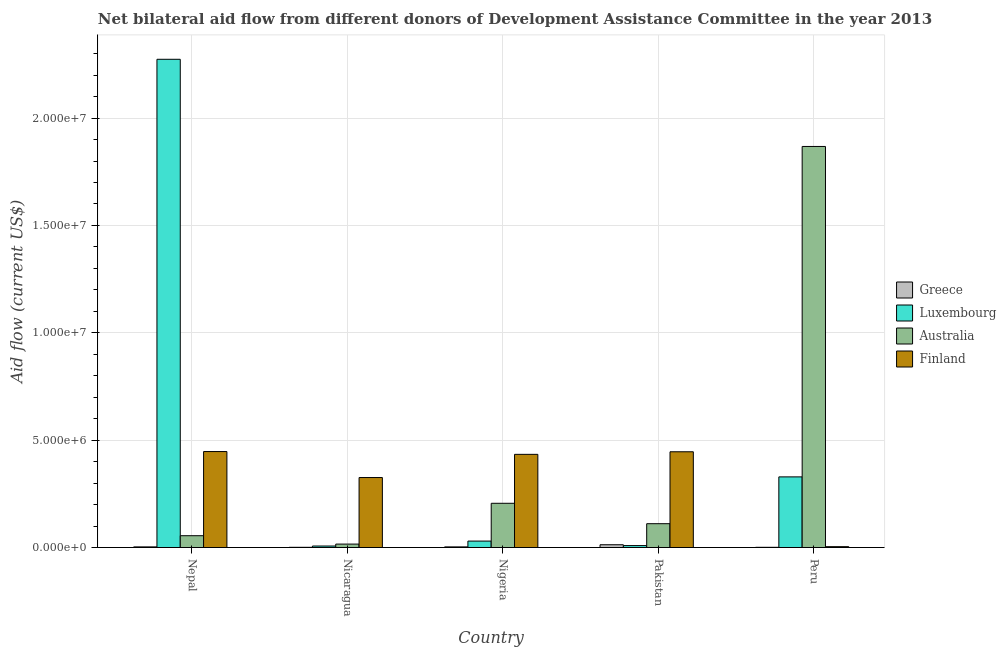How many groups of bars are there?
Offer a very short reply. 5. Are the number of bars per tick equal to the number of legend labels?
Provide a short and direct response. Yes. Are the number of bars on each tick of the X-axis equal?
Your answer should be compact. Yes. How many bars are there on the 5th tick from the right?
Keep it short and to the point. 4. What is the label of the 3rd group of bars from the left?
Your response must be concise. Nigeria. In how many cases, is the number of bars for a given country not equal to the number of legend labels?
Keep it short and to the point. 0. What is the amount of aid given by greece in Nepal?
Keep it short and to the point. 3.00e+04. Across all countries, what is the maximum amount of aid given by greece?
Your response must be concise. 1.30e+05. Across all countries, what is the minimum amount of aid given by greece?
Provide a short and direct response. 10000. In which country was the amount of aid given by greece maximum?
Give a very brief answer. Pakistan. In which country was the amount of aid given by greece minimum?
Your response must be concise. Nicaragua. What is the total amount of aid given by luxembourg in the graph?
Your response must be concise. 2.65e+07. What is the difference between the amount of aid given by greece in Nigeria and that in Peru?
Make the answer very short. 2.00e+04. What is the difference between the amount of aid given by luxembourg in Nepal and the amount of aid given by greece in Nicaragua?
Provide a short and direct response. 2.27e+07. What is the average amount of aid given by luxembourg per country?
Offer a terse response. 5.30e+06. What is the difference between the amount of aid given by luxembourg and amount of aid given by finland in Nigeria?
Give a very brief answer. -4.04e+06. In how many countries, is the amount of aid given by luxembourg greater than 22000000 US$?
Your response must be concise. 1. What is the ratio of the amount of aid given by luxembourg in Nepal to that in Nicaragua?
Your response must be concise. 324.86. Is the difference between the amount of aid given by australia in Nepal and Pakistan greater than the difference between the amount of aid given by greece in Nepal and Pakistan?
Provide a succinct answer. No. What is the difference between the highest and the second highest amount of aid given by finland?
Your answer should be compact. 10000. What is the difference between the highest and the lowest amount of aid given by greece?
Provide a short and direct response. 1.20e+05. What does the 2nd bar from the left in Pakistan represents?
Your response must be concise. Luxembourg. Is it the case that in every country, the sum of the amount of aid given by greece and amount of aid given by luxembourg is greater than the amount of aid given by australia?
Give a very brief answer. No. How many bars are there?
Keep it short and to the point. 20. What is the difference between two consecutive major ticks on the Y-axis?
Your answer should be compact. 5.00e+06. Are the values on the major ticks of Y-axis written in scientific E-notation?
Offer a very short reply. Yes. Does the graph contain grids?
Your response must be concise. Yes. How many legend labels are there?
Your response must be concise. 4. What is the title of the graph?
Your response must be concise. Net bilateral aid flow from different donors of Development Assistance Committee in the year 2013. Does "Taxes on income" appear as one of the legend labels in the graph?
Provide a succinct answer. No. What is the label or title of the X-axis?
Make the answer very short. Country. What is the label or title of the Y-axis?
Provide a succinct answer. Aid flow (current US$). What is the Aid flow (current US$) of Greece in Nepal?
Ensure brevity in your answer.  3.00e+04. What is the Aid flow (current US$) in Luxembourg in Nepal?
Make the answer very short. 2.27e+07. What is the Aid flow (current US$) of Australia in Nepal?
Your answer should be compact. 5.50e+05. What is the Aid flow (current US$) in Finland in Nepal?
Keep it short and to the point. 4.47e+06. What is the Aid flow (current US$) in Greece in Nicaragua?
Give a very brief answer. 10000. What is the Aid flow (current US$) in Luxembourg in Nicaragua?
Provide a short and direct response. 7.00e+04. What is the Aid flow (current US$) of Finland in Nicaragua?
Your answer should be compact. 3.26e+06. What is the Aid flow (current US$) in Greece in Nigeria?
Offer a terse response. 3.00e+04. What is the Aid flow (current US$) of Luxembourg in Nigeria?
Ensure brevity in your answer.  3.00e+05. What is the Aid flow (current US$) in Australia in Nigeria?
Ensure brevity in your answer.  2.06e+06. What is the Aid flow (current US$) of Finland in Nigeria?
Give a very brief answer. 4.34e+06. What is the Aid flow (current US$) of Greece in Pakistan?
Give a very brief answer. 1.30e+05. What is the Aid flow (current US$) in Luxembourg in Pakistan?
Your answer should be compact. 9.00e+04. What is the Aid flow (current US$) of Australia in Pakistan?
Give a very brief answer. 1.11e+06. What is the Aid flow (current US$) of Finland in Pakistan?
Your response must be concise. 4.46e+06. What is the Aid flow (current US$) in Greece in Peru?
Give a very brief answer. 10000. What is the Aid flow (current US$) in Luxembourg in Peru?
Ensure brevity in your answer.  3.29e+06. What is the Aid flow (current US$) of Australia in Peru?
Your answer should be very brief. 1.87e+07. Across all countries, what is the maximum Aid flow (current US$) in Greece?
Make the answer very short. 1.30e+05. Across all countries, what is the maximum Aid flow (current US$) of Luxembourg?
Provide a short and direct response. 2.27e+07. Across all countries, what is the maximum Aid flow (current US$) of Australia?
Keep it short and to the point. 1.87e+07. Across all countries, what is the maximum Aid flow (current US$) of Finland?
Ensure brevity in your answer.  4.47e+06. Across all countries, what is the minimum Aid flow (current US$) of Australia?
Offer a terse response. 1.60e+05. What is the total Aid flow (current US$) in Greece in the graph?
Ensure brevity in your answer.  2.10e+05. What is the total Aid flow (current US$) in Luxembourg in the graph?
Offer a very short reply. 2.65e+07. What is the total Aid flow (current US$) in Australia in the graph?
Keep it short and to the point. 2.26e+07. What is the total Aid flow (current US$) in Finland in the graph?
Provide a succinct answer. 1.66e+07. What is the difference between the Aid flow (current US$) of Luxembourg in Nepal and that in Nicaragua?
Provide a short and direct response. 2.27e+07. What is the difference between the Aid flow (current US$) in Australia in Nepal and that in Nicaragua?
Offer a very short reply. 3.90e+05. What is the difference between the Aid flow (current US$) of Finland in Nepal and that in Nicaragua?
Your response must be concise. 1.21e+06. What is the difference between the Aid flow (current US$) in Luxembourg in Nepal and that in Nigeria?
Your response must be concise. 2.24e+07. What is the difference between the Aid flow (current US$) of Australia in Nepal and that in Nigeria?
Keep it short and to the point. -1.51e+06. What is the difference between the Aid flow (current US$) of Luxembourg in Nepal and that in Pakistan?
Offer a very short reply. 2.26e+07. What is the difference between the Aid flow (current US$) of Australia in Nepal and that in Pakistan?
Provide a succinct answer. -5.60e+05. What is the difference between the Aid flow (current US$) in Luxembourg in Nepal and that in Peru?
Provide a succinct answer. 1.94e+07. What is the difference between the Aid flow (current US$) of Australia in Nepal and that in Peru?
Make the answer very short. -1.81e+07. What is the difference between the Aid flow (current US$) in Finland in Nepal and that in Peru?
Your response must be concise. 4.43e+06. What is the difference between the Aid flow (current US$) of Greece in Nicaragua and that in Nigeria?
Offer a very short reply. -2.00e+04. What is the difference between the Aid flow (current US$) in Luxembourg in Nicaragua and that in Nigeria?
Your answer should be very brief. -2.30e+05. What is the difference between the Aid flow (current US$) of Australia in Nicaragua and that in Nigeria?
Your answer should be very brief. -1.90e+06. What is the difference between the Aid flow (current US$) of Finland in Nicaragua and that in Nigeria?
Offer a terse response. -1.08e+06. What is the difference between the Aid flow (current US$) in Luxembourg in Nicaragua and that in Pakistan?
Offer a terse response. -2.00e+04. What is the difference between the Aid flow (current US$) of Australia in Nicaragua and that in Pakistan?
Give a very brief answer. -9.50e+05. What is the difference between the Aid flow (current US$) of Finland in Nicaragua and that in Pakistan?
Offer a terse response. -1.20e+06. What is the difference between the Aid flow (current US$) of Luxembourg in Nicaragua and that in Peru?
Offer a terse response. -3.22e+06. What is the difference between the Aid flow (current US$) of Australia in Nicaragua and that in Peru?
Keep it short and to the point. -1.85e+07. What is the difference between the Aid flow (current US$) in Finland in Nicaragua and that in Peru?
Provide a succinct answer. 3.22e+06. What is the difference between the Aid flow (current US$) of Greece in Nigeria and that in Pakistan?
Your answer should be compact. -1.00e+05. What is the difference between the Aid flow (current US$) of Australia in Nigeria and that in Pakistan?
Your answer should be compact. 9.50e+05. What is the difference between the Aid flow (current US$) of Finland in Nigeria and that in Pakistan?
Ensure brevity in your answer.  -1.20e+05. What is the difference between the Aid flow (current US$) of Luxembourg in Nigeria and that in Peru?
Your answer should be very brief. -2.99e+06. What is the difference between the Aid flow (current US$) in Australia in Nigeria and that in Peru?
Give a very brief answer. -1.66e+07. What is the difference between the Aid flow (current US$) in Finland in Nigeria and that in Peru?
Offer a very short reply. 4.30e+06. What is the difference between the Aid flow (current US$) of Luxembourg in Pakistan and that in Peru?
Ensure brevity in your answer.  -3.20e+06. What is the difference between the Aid flow (current US$) in Australia in Pakistan and that in Peru?
Your answer should be very brief. -1.76e+07. What is the difference between the Aid flow (current US$) in Finland in Pakistan and that in Peru?
Your answer should be compact. 4.42e+06. What is the difference between the Aid flow (current US$) of Greece in Nepal and the Aid flow (current US$) of Luxembourg in Nicaragua?
Keep it short and to the point. -4.00e+04. What is the difference between the Aid flow (current US$) in Greece in Nepal and the Aid flow (current US$) in Finland in Nicaragua?
Offer a terse response. -3.23e+06. What is the difference between the Aid flow (current US$) of Luxembourg in Nepal and the Aid flow (current US$) of Australia in Nicaragua?
Provide a short and direct response. 2.26e+07. What is the difference between the Aid flow (current US$) in Luxembourg in Nepal and the Aid flow (current US$) in Finland in Nicaragua?
Your response must be concise. 1.95e+07. What is the difference between the Aid flow (current US$) in Australia in Nepal and the Aid flow (current US$) in Finland in Nicaragua?
Give a very brief answer. -2.71e+06. What is the difference between the Aid flow (current US$) in Greece in Nepal and the Aid flow (current US$) in Luxembourg in Nigeria?
Offer a terse response. -2.70e+05. What is the difference between the Aid flow (current US$) in Greece in Nepal and the Aid flow (current US$) in Australia in Nigeria?
Provide a short and direct response. -2.03e+06. What is the difference between the Aid flow (current US$) of Greece in Nepal and the Aid flow (current US$) of Finland in Nigeria?
Your answer should be very brief. -4.31e+06. What is the difference between the Aid flow (current US$) in Luxembourg in Nepal and the Aid flow (current US$) in Australia in Nigeria?
Make the answer very short. 2.07e+07. What is the difference between the Aid flow (current US$) of Luxembourg in Nepal and the Aid flow (current US$) of Finland in Nigeria?
Give a very brief answer. 1.84e+07. What is the difference between the Aid flow (current US$) in Australia in Nepal and the Aid flow (current US$) in Finland in Nigeria?
Keep it short and to the point. -3.79e+06. What is the difference between the Aid flow (current US$) in Greece in Nepal and the Aid flow (current US$) in Luxembourg in Pakistan?
Provide a short and direct response. -6.00e+04. What is the difference between the Aid flow (current US$) in Greece in Nepal and the Aid flow (current US$) in Australia in Pakistan?
Offer a terse response. -1.08e+06. What is the difference between the Aid flow (current US$) of Greece in Nepal and the Aid flow (current US$) of Finland in Pakistan?
Make the answer very short. -4.43e+06. What is the difference between the Aid flow (current US$) of Luxembourg in Nepal and the Aid flow (current US$) of Australia in Pakistan?
Provide a short and direct response. 2.16e+07. What is the difference between the Aid flow (current US$) in Luxembourg in Nepal and the Aid flow (current US$) in Finland in Pakistan?
Keep it short and to the point. 1.83e+07. What is the difference between the Aid flow (current US$) of Australia in Nepal and the Aid flow (current US$) of Finland in Pakistan?
Keep it short and to the point. -3.91e+06. What is the difference between the Aid flow (current US$) in Greece in Nepal and the Aid flow (current US$) in Luxembourg in Peru?
Offer a terse response. -3.26e+06. What is the difference between the Aid flow (current US$) of Greece in Nepal and the Aid flow (current US$) of Australia in Peru?
Your answer should be compact. -1.86e+07. What is the difference between the Aid flow (current US$) of Luxembourg in Nepal and the Aid flow (current US$) of Australia in Peru?
Make the answer very short. 4.06e+06. What is the difference between the Aid flow (current US$) in Luxembourg in Nepal and the Aid flow (current US$) in Finland in Peru?
Your answer should be compact. 2.27e+07. What is the difference between the Aid flow (current US$) in Australia in Nepal and the Aid flow (current US$) in Finland in Peru?
Make the answer very short. 5.10e+05. What is the difference between the Aid flow (current US$) of Greece in Nicaragua and the Aid flow (current US$) of Australia in Nigeria?
Your response must be concise. -2.05e+06. What is the difference between the Aid flow (current US$) of Greece in Nicaragua and the Aid flow (current US$) of Finland in Nigeria?
Your answer should be very brief. -4.33e+06. What is the difference between the Aid flow (current US$) of Luxembourg in Nicaragua and the Aid flow (current US$) of Australia in Nigeria?
Offer a terse response. -1.99e+06. What is the difference between the Aid flow (current US$) of Luxembourg in Nicaragua and the Aid flow (current US$) of Finland in Nigeria?
Ensure brevity in your answer.  -4.27e+06. What is the difference between the Aid flow (current US$) of Australia in Nicaragua and the Aid flow (current US$) of Finland in Nigeria?
Offer a terse response. -4.18e+06. What is the difference between the Aid flow (current US$) in Greece in Nicaragua and the Aid flow (current US$) in Luxembourg in Pakistan?
Make the answer very short. -8.00e+04. What is the difference between the Aid flow (current US$) in Greece in Nicaragua and the Aid flow (current US$) in Australia in Pakistan?
Give a very brief answer. -1.10e+06. What is the difference between the Aid flow (current US$) in Greece in Nicaragua and the Aid flow (current US$) in Finland in Pakistan?
Offer a terse response. -4.45e+06. What is the difference between the Aid flow (current US$) in Luxembourg in Nicaragua and the Aid flow (current US$) in Australia in Pakistan?
Provide a short and direct response. -1.04e+06. What is the difference between the Aid flow (current US$) in Luxembourg in Nicaragua and the Aid flow (current US$) in Finland in Pakistan?
Your answer should be compact. -4.39e+06. What is the difference between the Aid flow (current US$) of Australia in Nicaragua and the Aid flow (current US$) of Finland in Pakistan?
Your answer should be very brief. -4.30e+06. What is the difference between the Aid flow (current US$) of Greece in Nicaragua and the Aid flow (current US$) of Luxembourg in Peru?
Your response must be concise. -3.28e+06. What is the difference between the Aid flow (current US$) of Greece in Nicaragua and the Aid flow (current US$) of Australia in Peru?
Offer a very short reply. -1.87e+07. What is the difference between the Aid flow (current US$) in Luxembourg in Nicaragua and the Aid flow (current US$) in Australia in Peru?
Keep it short and to the point. -1.86e+07. What is the difference between the Aid flow (current US$) in Greece in Nigeria and the Aid flow (current US$) in Australia in Pakistan?
Give a very brief answer. -1.08e+06. What is the difference between the Aid flow (current US$) in Greece in Nigeria and the Aid flow (current US$) in Finland in Pakistan?
Offer a terse response. -4.43e+06. What is the difference between the Aid flow (current US$) of Luxembourg in Nigeria and the Aid flow (current US$) of Australia in Pakistan?
Your response must be concise. -8.10e+05. What is the difference between the Aid flow (current US$) of Luxembourg in Nigeria and the Aid flow (current US$) of Finland in Pakistan?
Keep it short and to the point. -4.16e+06. What is the difference between the Aid flow (current US$) of Australia in Nigeria and the Aid flow (current US$) of Finland in Pakistan?
Your response must be concise. -2.40e+06. What is the difference between the Aid flow (current US$) in Greece in Nigeria and the Aid flow (current US$) in Luxembourg in Peru?
Keep it short and to the point. -3.26e+06. What is the difference between the Aid flow (current US$) of Greece in Nigeria and the Aid flow (current US$) of Australia in Peru?
Ensure brevity in your answer.  -1.86e+07. What is the difference between the Aid flow (current US$) of Luxembourg in Nigeria and the Aid flow (current US$) of Australia in Peru?
Ensure brevity in your answer.  -1.84e+07. What is the difference between the Aid flow (current US$) of Australia in Nigeria and the Aid flow (current US$) of Finland in Peru?
Offer a terse response. 2.02e+06. What is the difference between the Aid flow (current US$) of Greece in Pakistan and the Aid flow (current US$) of Luxembourg in Peru?
Keep it short and to the point. -3.16e+06. What is the difference between the Aid flow (current US$) of Greece in Pakistan and the Aid flow (current US$) of Australia in Peru?
Offer a very short reply. -1.86e+07. What is the difference between the Aid flow (current US$) of Luxembourg in Pakistan and the Aid flow (current US$) of Australia in Peru?
Offer a very short reply. -1.86e+07. What is the difference between the Aid flow (current US$) in Luxembourg in Pakistan and the Aid flow (current US$) in Finland in Peru?
Provide a short and direct response. 5.00e+04. What is the difference between the Aid flow (current US$) of Australia in Pakistan and the Aid flow (current US$) of Finland in Peru?
Make the answer very short. 1.07e+06. What is the average Aid flow (current US$) in Greece per country?
Your response must be concise. 4.20e+04. What is the average Aid flow (current US$) of Luxembourg per country?
Your answer should be compact. 5.30e+06. What is the average Aid flow (current US$) in Australia per country?
Give a very brief answer. 4.51e+06. What is the average Aid flow (current US$) in Finland per country?
Offer a very short reply. 3.31e+06. What is the difference between the Aid flow (current US$) of Greece and Aid flow (current US$) of Luxembourg in Nepal?
Offer a very short reply. -2.27e+07. What is the difference between the Aid flow (current US$) of Greece and Aid flow (current US$) of Australia in Nepal?
Ensure brevity in your answer.  -5.20e+05. What is the difference between the Aid flow (current US$) of Greece and Aid flow (current US$) of Finland in Nepal?
Your answer should be very brief. -4.44e+06. What is the difference between the Aid flow (current US$) of Luxembourg and Aid flow (current US$) of Australia in Nepal?
Provide a succinct answer. 2.22e+07. What is the difference between the Aid flow (current US$) in Luxembourg and Aid flow (current US$) in Finland in Nepal?
Your answer should be very brief. 1.83e+07. What is the difference between the Aid flow (current US$) of Australia and Aid flow (current US$) of Finland in Nepal?
Your answer should be compact. -3.92e+06. What is the difference between the Aid flow (current US$) in Greece and Aid flow (current US$) in Luxembourg in Nicaragua?
Ensure brevity in your answer.  -6.00e+04. What is the difference between the Aid flow (current US$) of Greece and Aid flow (current US$) of Finland in Nicaragua?
Make the answer very short. -3.25e+06. What is the difference between the Aid flow (current US$) of Luxembourg and Aid flow (current US$) of Australia in Nicaragua?
Give a very brief answer. -9.00e+04. What is the difference between the Aid flow (current US$) in Luxembourg and Aid flow (current US$) in Finland in Nicaragua?
Keep it short and to the point. -3.19e+06. What is the difference between the Aid flow (current US$) in Australia and Aid flow (current US$) in Finland in Nicaragua?
Your answer should be compact. -3.10e+06. What is the difference between the Aid flow (current US$) in Greece and Aid flow (current US$) in Luxembourg in Nigeria?
Provide a short and direct response. -2.70e+05. What is the difference between the Aid flow (current US$) in Greece and Aid flow (current US$) in Australia in Nigeria?
Offer a terse response. -2.03e+06. What is the difference between the Aid flow (current US$) in Greece and Aid flow (current US$) in Finland in Nigeria?
Provide a short and direct response. -4.31e+06. What is the difference between the Aid flow (current US$) of Luxembourg and Aid flow (current US$) of Australia in Nigeria?
Your answer should be compact. -1.76e+06. What is the difference between the Aid flow (current US$) of Luxembourg and Aid flow (current US$) of Finland in Nigeria?
Offer a terse response. -4.04e+06. What is the difference between the Aid flow (current US$) in Australia and Aid flow (current US$) in Finland in Nigeria?
Provide a succinct answer. -2.28e+06. What is the difference between the Aid flow (current US$) in Greece and Aid flow (current US$) in Australia in Pakistan?
Give a very brief answer. -9.80e+05. What is the difference between the Aid flow (current US$) in Greece and Aid flow (current US$) in Finland in Pakistan?
Your response must be concise. -4.33e+06. What is the difference between the Aid flow (current US$) of Luxembourg and Aid flow (current US$) of Australia in Pakistan?
Make the answer very short. -1.02e+06. What is the difference between the Aid flow (current US$) in Luxembourg and Aid flow (current US$) in Finland in Pakistan?
Your response must be concise. -4.37e+06. What is the difference between the Aid flow (current US$) in Australia and Aid flow (current US$) in Finland in Pakistan?
Give a very brief answer. -3.35e+06. What is the difference between the Aid flow (current US$) of Greece and Aid flow (current US$) of Luxembourg in Peru?
Offer a very short reply. -3.28e+06. What is the difference between the Aid flow (current US$) of Greece and Aid flow (current US$) of Australia in Peru?
Your response must be concise. -1.87e+07. What is the difference between the Aid flow (current US$) in Luxembourg and Aid flow (current US$) in Australia in Peru?
Your answer should be very brief. -1.54e+07. What is the difference between the Aid flow (current US$) of Luxembourg and Aid flow (current US$) of Finland in Peru?
Provide a succinct answer. 3.25e+06. What is the difference between the Aid flow (current US$) of Australia and Aid flow (current US$) of Finland in Peru?
Provide a short and direct response. 1.86e+07. What is the ratio of the Aid flow (current US$) in Greece in Nepal to that in Nicaragua?
Your answer should be very brief. 3. What is the ratio of the Aid flow (current US$) of Luxembourg in Nepal to that in Nicaragua?
Provide a short and direct response. 324.86. What is the ratio of the Aid flow (current US$) of Australia in Nepal to that in Nicaragua?
Provide a short and direct response. 3.44. What is the ratio of the Aid flow (current US$) of Finland in Nepal to that in Nicaragua?
Offer a terse response. 1.37. What is the ratio of the Aid flow (current US$) of Greece in Nepal to that in Nigeria?
Offer a very short reply. 1. What is the ratio of the Aid flow (current US$) of Luxembourg in Nepal to that in Nigeria?
Offer a terse response. 75.8. What is the ratio of the Aid flow (current US$) in Australia in Nepal to that in Nigeria?
Ensure brevity in your answer.  0.27. What is the ratio of the Aid flow (current US$) in Finland in Nepal to that in Nigeria?
Keep it short and to the point. 1.03. What is the ratio of the Aid flow (current US$) in Greece in Nepal to that in Pakistan?
Keep it short and to the point. 0.23. What is the ratio of the Aid flow (current US$) of Luxembourg in Nepal to that in Pakistan?
Offer a terse response. 252.67. What is the ratio of the Aid flow (current US$) of Australia in Nepal to that in Pakistan?
Your response must be concise. 0.5. What is the ratio of the Aid flow (current US$) of Finland in Nepal to that in Pakistan?
Your response must be concise. 1. What is the ratio of the Aid flow (current US$) of Greece in Nepal to that in Peru?
Your answer should be very brief. 3. What is the ratio of the Aid flow (current US$) of Luxembourg in Nepal to that in Peru?
Your answer should be very brief. 6.91. What is the ratio of the Aid flow (current US$) in Australia in Nepal to that in Peru?
Your answer should be compact. 0.03. What is the ratio of the Aid flow (current US$) of Finland in Nepal to that in Peru?
Your answer should be very brief. 111.75. What is the ratio of the Aid flow (current US$) of Greece in Nicaragua to that in Nigeria?
Ensure brevity in your answer.  0.33. What is the ratio of the Aid flow (current US$) of Luxembourg in Nicaragua to that in Nigeria?
Your answer should be compact. 0.23. What is the ratio of the Aid flow (current US$) of Australia in Nicaragua to that in Nigeria?
Ensure brevity in your answer.  0.08. What is the ratio of the Aid flow (current US$) in Finland in Nicaragua to that in Nigeria?
Give a very brief answer. 0.75. What is the ratio of the Aid flow (current US$) of Greece in Nicaragua to that in Pakistan?
Your answer should be very brief. 0.08. What is the ratio of the Aid flow (current US$) in Australia in Nicaragua to that in Pakistan?
Provide a short and direct response. 0.14. What is the ratio of the Aid flow (current US$) in Finland in Nicaragua to that in Pakistan?
Ensure brevity in your answer.  0.73. What is the ratio of the Aid flow (current US$) of Greece in Nicaragua to that in Peru?
Provide a short and direct response. 1. What is the ratio of the Aid flow (current US$) in Luxembourg in Nicaragua to that in Peru?
Ensure brevity in your answer.  0.02. What is the ratio of the Aid flow (current US$) of Australia in Nicaragua to that in Peru?
Keep it short and to the point. 0.01. What is the ratio of the Aid flow (current US$) in Finland in Nicaragua to that in Peru?
Make the answer very short. 81.5. What is the ratio of the Aid flow (current US$) of Greece in Nigeria to that in Pakistan?
Ensure brevity in your answer.  0.23. What is the ratio of the Aid flow (current US$) of Luxembourg in Nigeria to that in Pakistan?
Offer a terse response. 3.33. What is the ratio of the Aid flow (current US$) in Australia in Nigeria to that in Pakistan?
Your answer should be compact. 1.86. What is the ratio of the Aid flow (current US$) in Finland in Nigeria to that in Pakistan?
Ensure brevity in your answer.  0.97. What is the ratio of the Aid flow (current US$) of Greece in Nigeria to that in Peru?
Provide a succinct answer. 3. What is the ratio of the Aid flow (current US$) of Luxembourg in Nigeria to that in Peru?
Make the answer very short. 0.09. What is the ratio of the Aid flow (current US$) of Australia in Nigeria to that in Peru?
Ensure brevity in your answer.  0.11. What is the ratio of the Aid flow (current US$) of Finland in Nigeria to that in Peru?
Give a very brief answer. 108.5. What is the ratio of the Aid flow (current US$) of Luxembourg in Pakistan to that in Peru?
Your answer should be compact. 0.03. What is the ratio of the Aid flow (current US$) in Australia in Pakistan to that in Peru?
Keep it short and to the point. 0.06. What is the ratio of the Aid flow (current US$) in Finland in Pakistan to that in Peru?
Provide a short and direct response. 111.5. What is the difference between the highest and the second highest Aid flow (current US$) in Luxembourg?
Your answer should be very brief. 1.94e+07. What is the difference between the highest and the second highest Aid flow (current US$) in Australia?
Keep it short and to the point. 1.66e+07. What is the difference between the highest and the lowest Aid flow (current US$) in Luxembourg?
Ensure brevity in your answer.  2.27e+07. What is the difference between the highest and the lowest Aid flow (current US$) in Australia?
Your answer should be very brief. 1.85e+07. What is the difference between the highest and the lowest Aid flow (current US$) in Finland?
Give a very brief answer. 4.43e+06. 